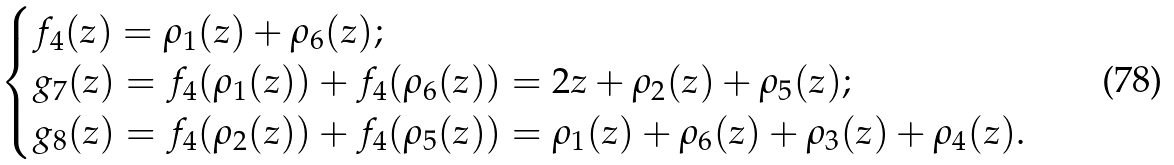<formula> <loc_0><loc_0><loc_500><loc_500>\begin{cases} f _ { 4 } ( z ) = \rho _ { 1 } ( z ) + \rho _ { 6 } ( z ) ; \\ g _ { 7 } ( z ) = f _ { 4 } ( \rho _ { 1 } ( z ) ) + f _ { 4 } ( \rho _ { 6 } ( z ) ) = 2 z + \rho _ { 2 } ( z ) + \rho _ { 5 } ( z ) ; \\ g _ { 8 } ( z ) = f _ { 4 } ( \rho _ { 2 } ( z ) ) + f _ { 4 } ( \rho _ { 5 } ( z ) ) = \rho _ { 1 } ( z ) + \rho _ { 6 } ( z ) + \rho _ { 3 } ( z ) + \rho _ { 4 } ( z ) . \end{cases}</formula> 